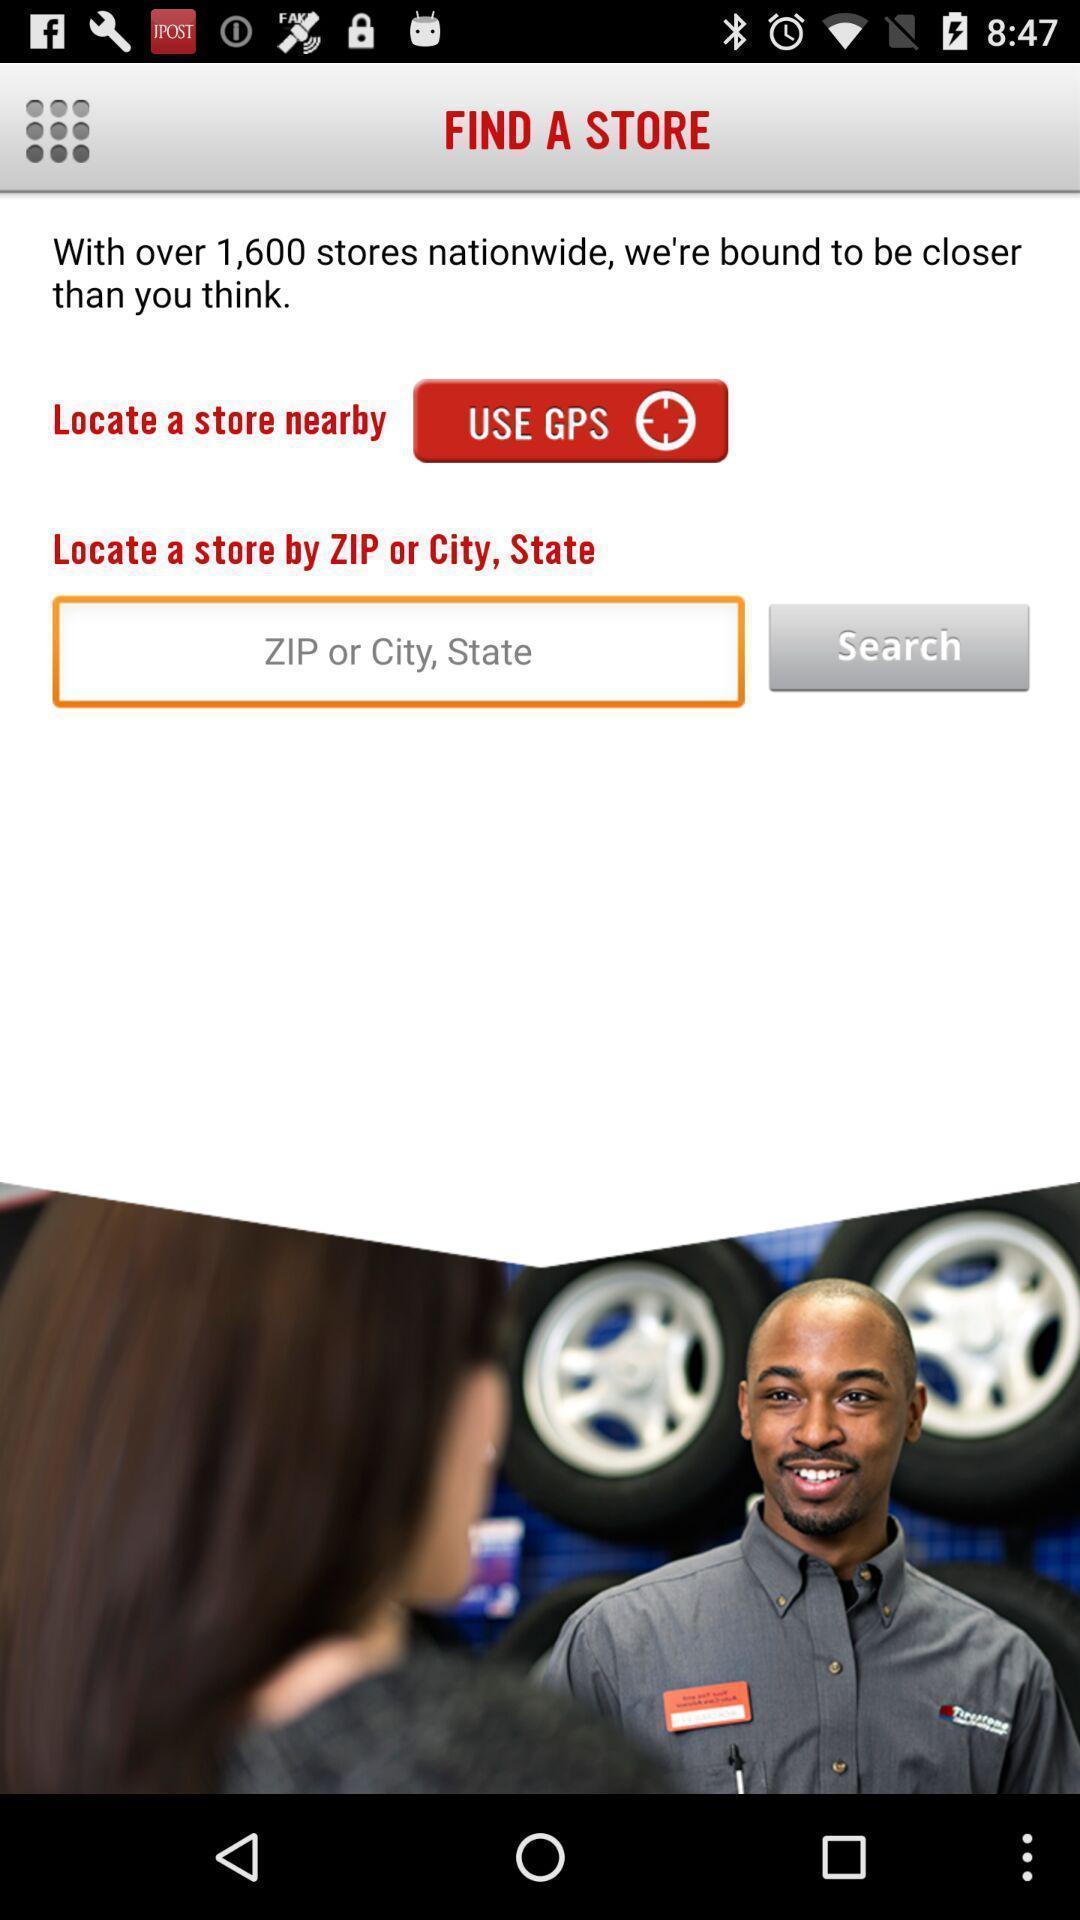Explain what's happening in this screen capture. Search bar to search a store using city name. 